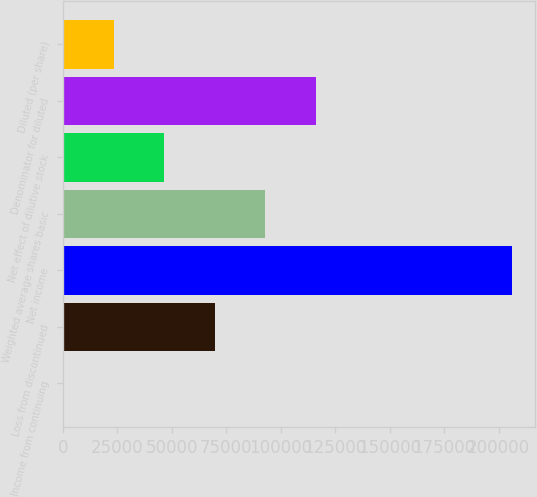<chart> <loc_0><loc_0><loc_500><loc_500><bar_chart><fcel>Income from continuing<fcel>Loss from discontinued<fcel>Net income<fcel>Weighted average shares basic<fcel>Net effect of dilutive stock<fcel>Denominator for diluted<fcel>Diluted (per share)<nl><fcel>0.36<fcel>69765.8<fcel>206402<fcel>93021<fcel>46510.7<fcel>116276<fcel>23255.5<nl></chart> 